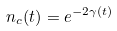<formula> <loc_0><loc_0><loc_500><loc_500>n _ { c } ( t ) = e ^ { - 2 \gamma ( t ) }</formula> 